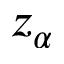<formula> <loc_0><loc_0><loc_500><loc_500>z _ { \alpha }</formula> 